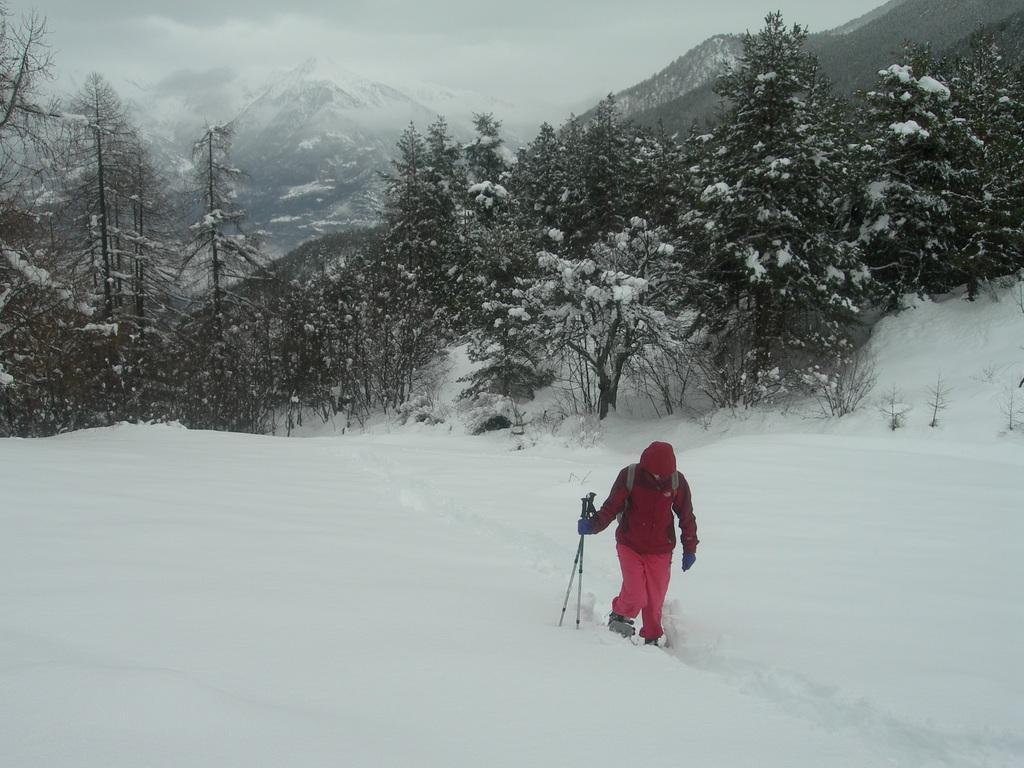In one or two sentences, can you explain what this image depicts? In this image I can see ground full of snow and on it I can see one person is standing in the front. I can see this person is wearing red colour dress, gloves and I can also see this person is holding few sticks. In the background I can see number of trees and mountains. 